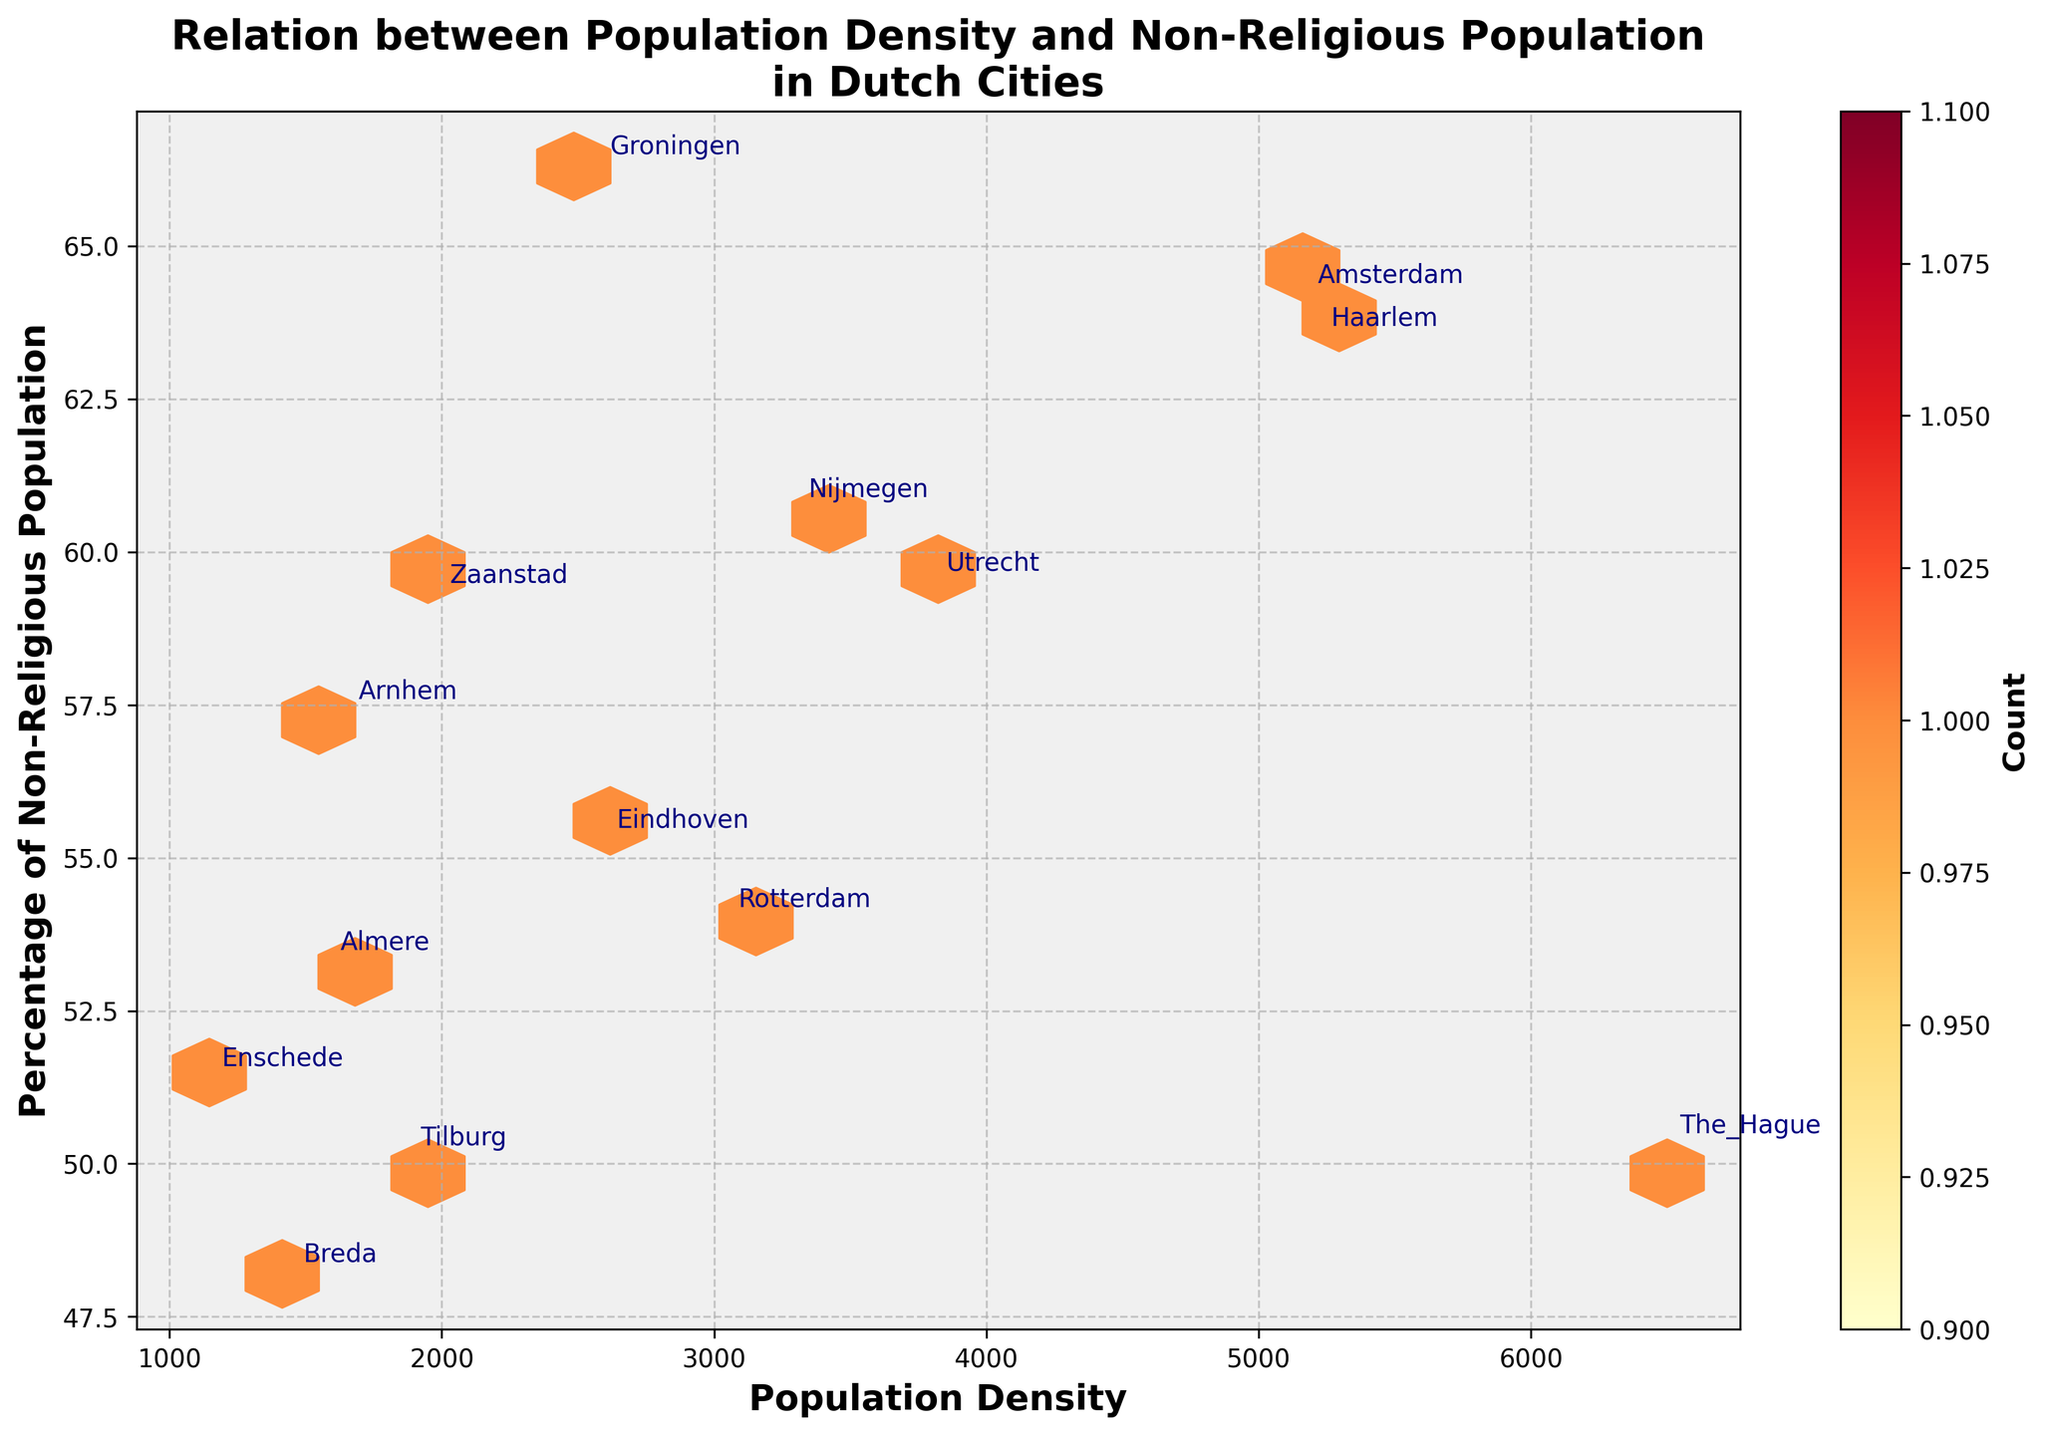What is the title of the hexbin plot? The title is located at the top of the figure and provides a summary of what the plot is about. Looking at the plot helps identify its main focus.
Answer: Relation between Population Density and Non-Religious Population in Dutch Cities What do the x and y axes represent in the plot? The labels on the x and y axes are clearly marked, and they tell us what variables are being plotted. The x-axis label is "Population Density" and the y-axis label is "Percentage of Non-Religious Population."
Answer: x-axis: Population Density, y-axis: Percentage of Non-Religious Population What does the color intensity in the hexbin plot signify? The color intensity in a hexbin plot typically represents the count or frequency of data points within each bin. The color bar on the right side of the plot indicates this.
Answer: Count of data points Which city has the highest population density? The cities are annotated on the plot. The one with the highest population density will be the one farthest to the right on the x-axis. By examining the city names, we can identify the city with the highest population density.
Answer: The Hague Which city has the highest percentage of non-religious population? By checking the city labels and their corresponding y-values on the plot, we can pinpoint the city with the highest percentage on the y-axis.
Answer: Groningen How does the population density relate to the percentage of non-religious population? To answer this, observe if there is any apparent trend in the distribution of data points from left to right and how they align vertically.
Answer: Higher population density does not necessarily correspond to a higher percentage of non-religious population Which city has a relatively low population density but a high percentage of non-religious population? Look for a city positioned lower on the x-axis (low population density) but higher on the y-axis (high non-religious population percentage).
Answer: Nijmegen How many cities have a population density greater than 3000 but a non-religious population less than 60%? Count the annotated cities that fall into the area where the x-value is greater than 3000 and the y-value is less than 60%.
Answer: Three cities (Amsterdam, Rotterdam, Utrecht) Is there a city with both high population density and a low percentage of non-religious population compared to the others? Look for a city that is situated far to the right on the x-axis (high population density) yet low on the y-axis (low percentage of non-religious population) compared to other cities.
Answer: The Hague 